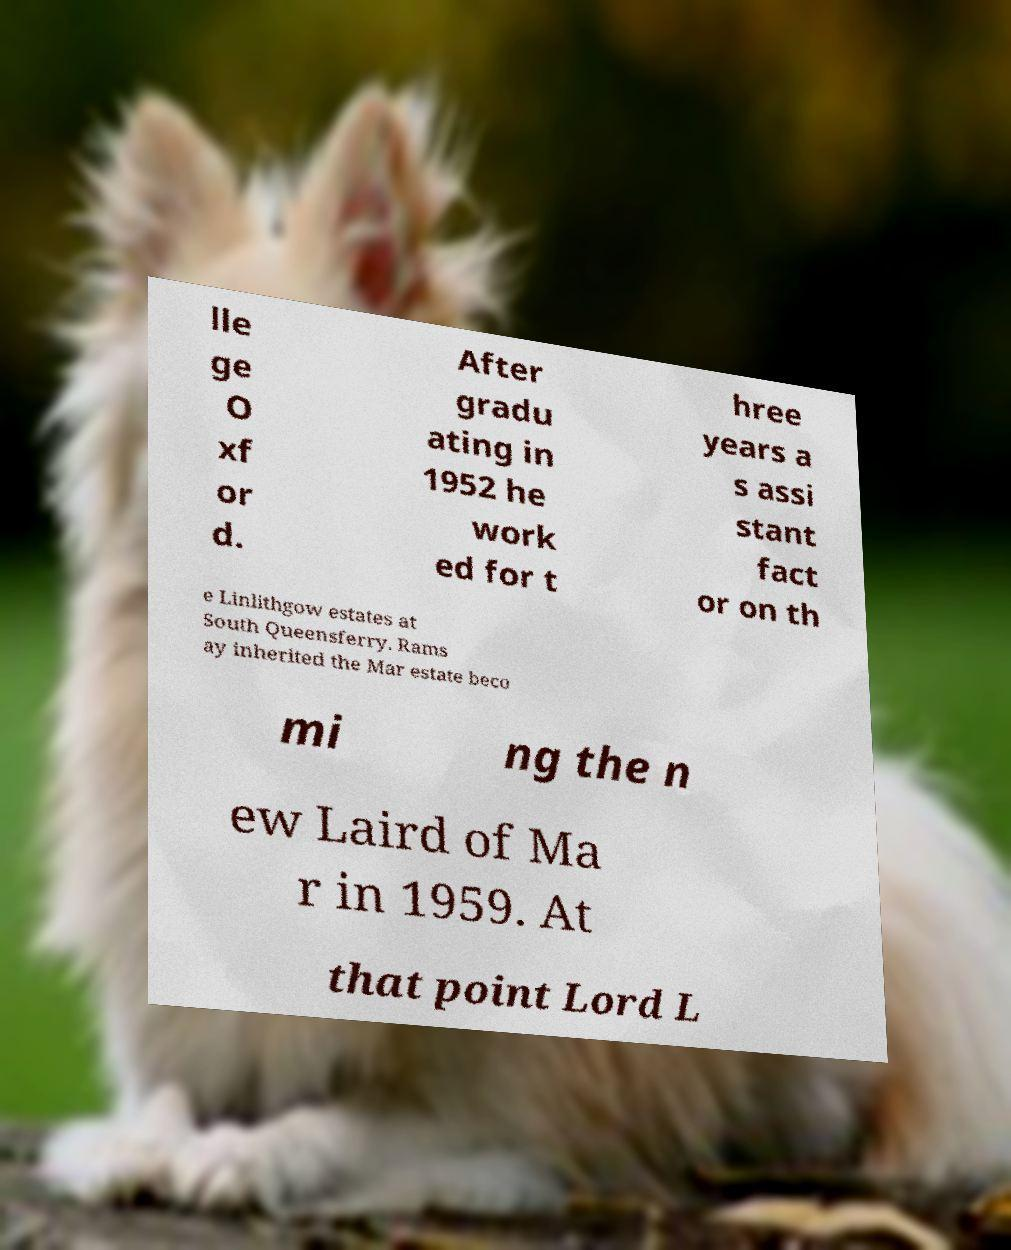I need the written content from this picture converted into text. Can you do that? lle ge O xf or d. After gradu ating in 1952 he work ed for t hree years a s assi stant fact or on th e Linlithgow estates at South Queensferry. Rams ay inherited the Mar estate beco mi ng the n ew Laird of Ma r in 1959. At that point Lord L 